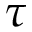<formula> <loc_0><loc_0><loc_500><loc_500>\tau</formula> 